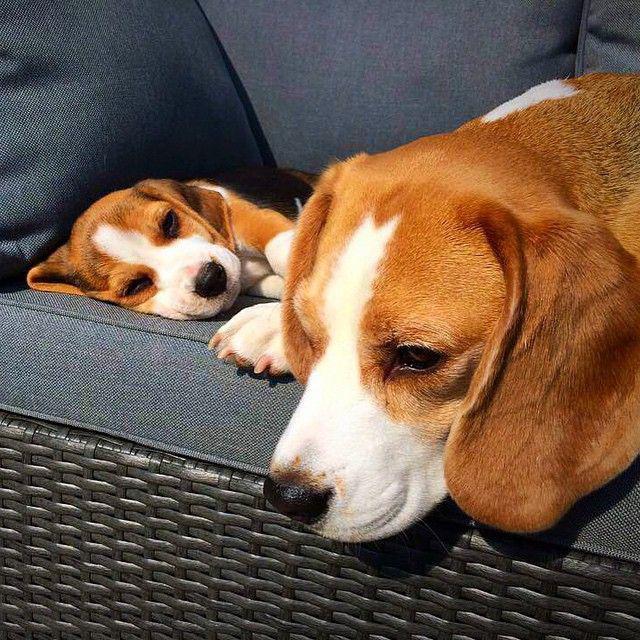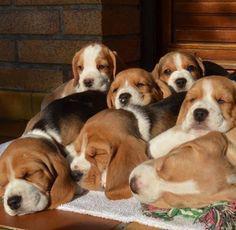The first image is the image on the left, the second image is the image on the right. Analyze the images presented: Is the assertion "A total of four beagles are shown, and at least one beagle is posed on an upholstered seat." valid? Answer yes or no. No. The first image is the image on the left, the second image is the image on the right. Given the left and right images, does the statement "There is exactly two dogs in the right image." hold true? Answer yes or no. No. 